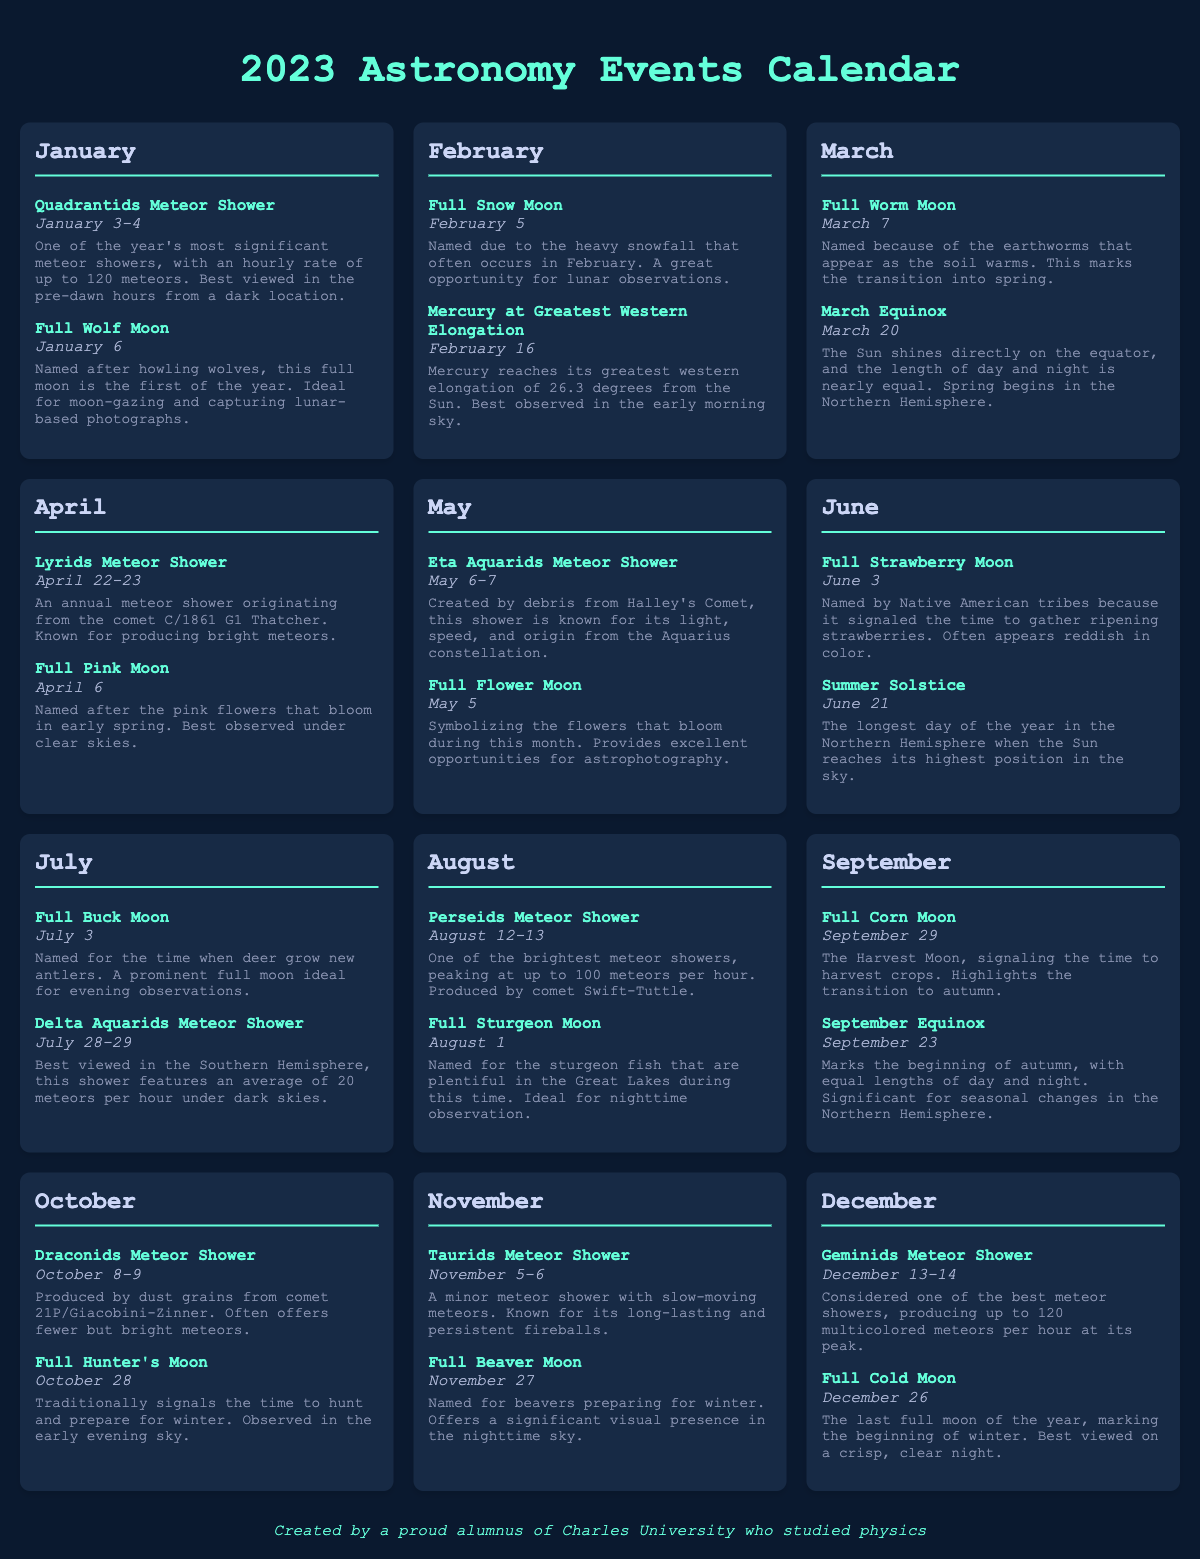What are the dates for the Quadrantids Meteor Shower? The document specifies that the Quadrantids Meteor Shower occurs on January 3-4.
Answer: January 3-4 What is the name of the full moon in March? The calendar lists the full moon in March as the Full Worm Moon.
Answer: Full Worm Moon What meteor shower peaks in August? The document indicates that the Perseids Meteor Shower peaks in August.
Answer: Perseids Meteor Shower When is the Summer Solstice in 2023? According to the document, the Summer Solstice occurs on June 21.
Answer: June 21 How many meteors per hour can be observed during the Geminids Meteor Shower? The calendar notes that the Geminids Meteor Shower can produce up to 120 meteors per hour at its peak.
Answer: 120 Which month has the Lyrids Meteor Shower? The document states that the Lyrids Meteor Shower occurs in April.
Answer: April What is the significance of the September Equinox? The document explains that the September Equinox marks the beginning of autumn with equal lengths of day and night.
Answer: Beginning of autumn What is the last full moon of the year called? The document identifies the last full moon of the year as the Full Cold Moon.
Answer: Full Cold Moon When does the Eta Aquarids Meteor Shower occur? The calendar lists the Eta Aquarids Meteor Shower as occurring on May 6-7.
Answer: May 6-7 